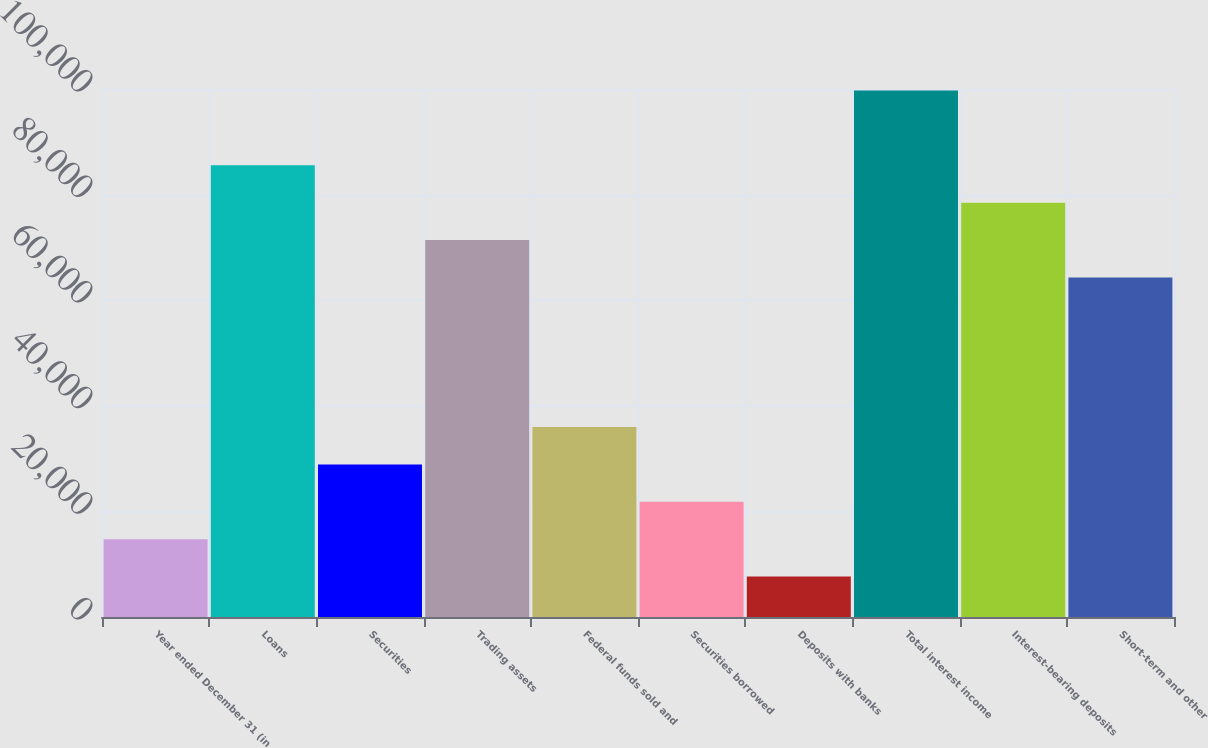<chart> <loc_0><loc_0><loc_500><loc_500><bar_chart><fcel>Year ended December 31 (in<fcel>Loans<fcel>Securities<fcel>Trading assets<fcel>Federal funds sold and<fcel>Securities borrowed<fcel>Deposits with banks<fcel>Total interest income<fcel>Interest-bearing deposits<fcel>Short-term and other<nl><fcel>14741.4<fcel>85548.4<fcel>28902.8<fcel>71387<fcel>35983.5<fcel>21822.1<fcel>7660.7<fcel>99709.8<fcel>78467.7<fcel>64306.3<nl></chart> 